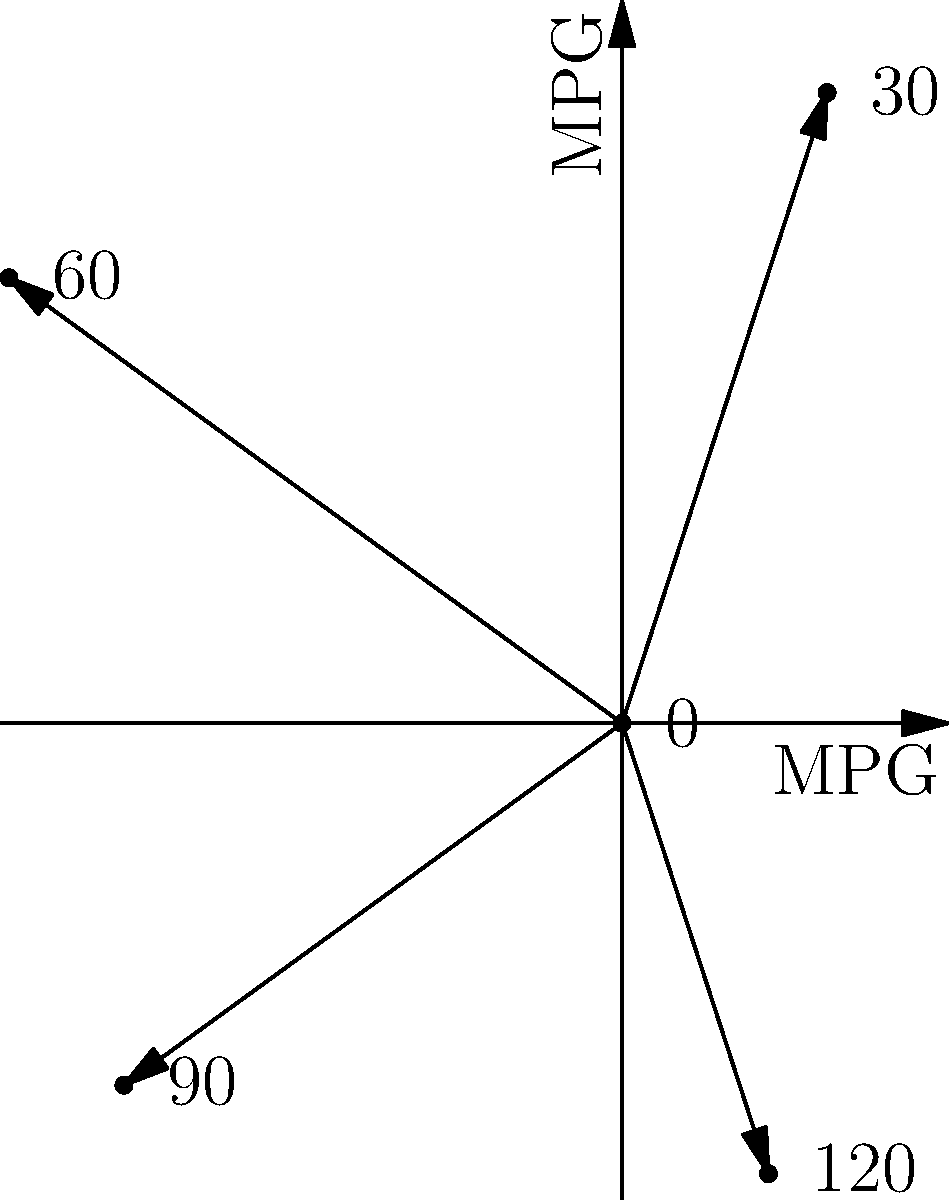As a UX designer for automotive websites, you're tasked with creating an intuitive polar graph to represent fuel efficiency at different speeds. The graph shows MPG (miles per gallon) values for speeds of 0, 30, 60, 90, and 120 mph. What speed corresponds to the highest fuel efficiency, and how would you improve the graph's readability for users? To answer this question, let's analyze the polar graph step by step:

1. The graph represents fuel efficiency (MPG) at different speeds using a polar coordinate system.
2. Each spoke of the graph represents a different speed: 0, 30, 60, 90, and 120 mph.
3. The length of each spoke represents the MPG value for that speed.
4. To find the highest fuel efficiency, we need to identify the longest spoke:
   - 0 mph: 0 MPG (stationary vehicle)
   - 30 mph: 2.8 units (28 MPG)
   - 60 mph: 3.2 units (32 MPG)
   - 90 mph: 2.6 units (26 MPG)
   - 120 mph: 2.0 units (20 MPG)
5. The longest spoke corresponds to 60 mph, indicating the highest fuel efficiency of 32 MPG.

To improve the graph's readability for users:
a) Add concentric circles to represent MPG values (e.g., 10, 20, 30 MPG).
b) Use color coding to differentiate between efficient and inefficient speeds.
c) Add labels for MPG values at the end of each spoke.
d) Include a legend explaining the relationship between spoke length and MPG.
e) Consider using a smoother curve to connect the data points, showing the trend of fuel efficiency across speeds.
Answer: 60 mph; add concentric circles, color coding, MPG labels, legend, and trend curve. 